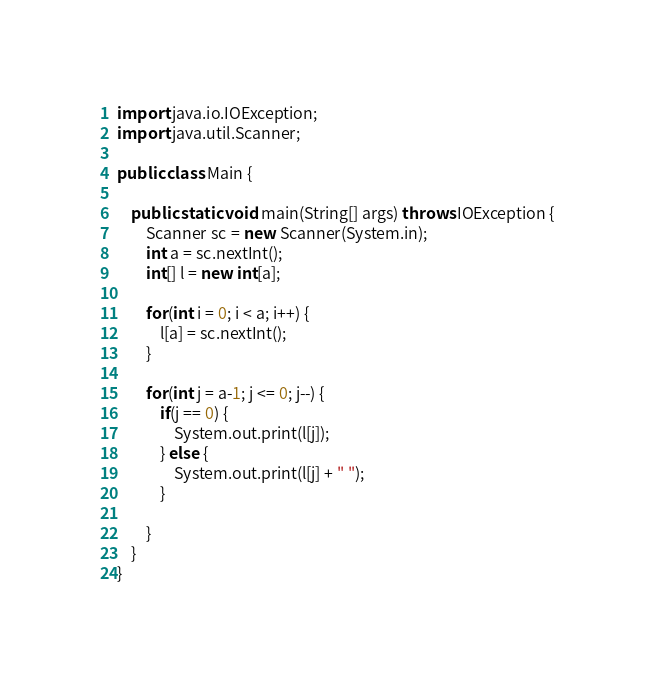<code> <loc_0><loc_0><loc_500><loc_500><_Java_>import java.io.IOException;
import java.util.Scanner;

public class Main {

	public static void main(String[] args) throws IOException {
		Scanner sc = new Scanner(System.in);
        int a = sc.nextInt();
        int[] l = new int[a];

        for(int i = 0; i < a; i++) {
        	l[a] = sc.nextInt();
        }

        for(int j = a-1; j <= 0; j--) {
        	if(j == 0) {
            	System.out.print(l[j]);
        	} else {
            	System.out.print(l[j] + " ");
        	}

        }
	}
}

</code> 